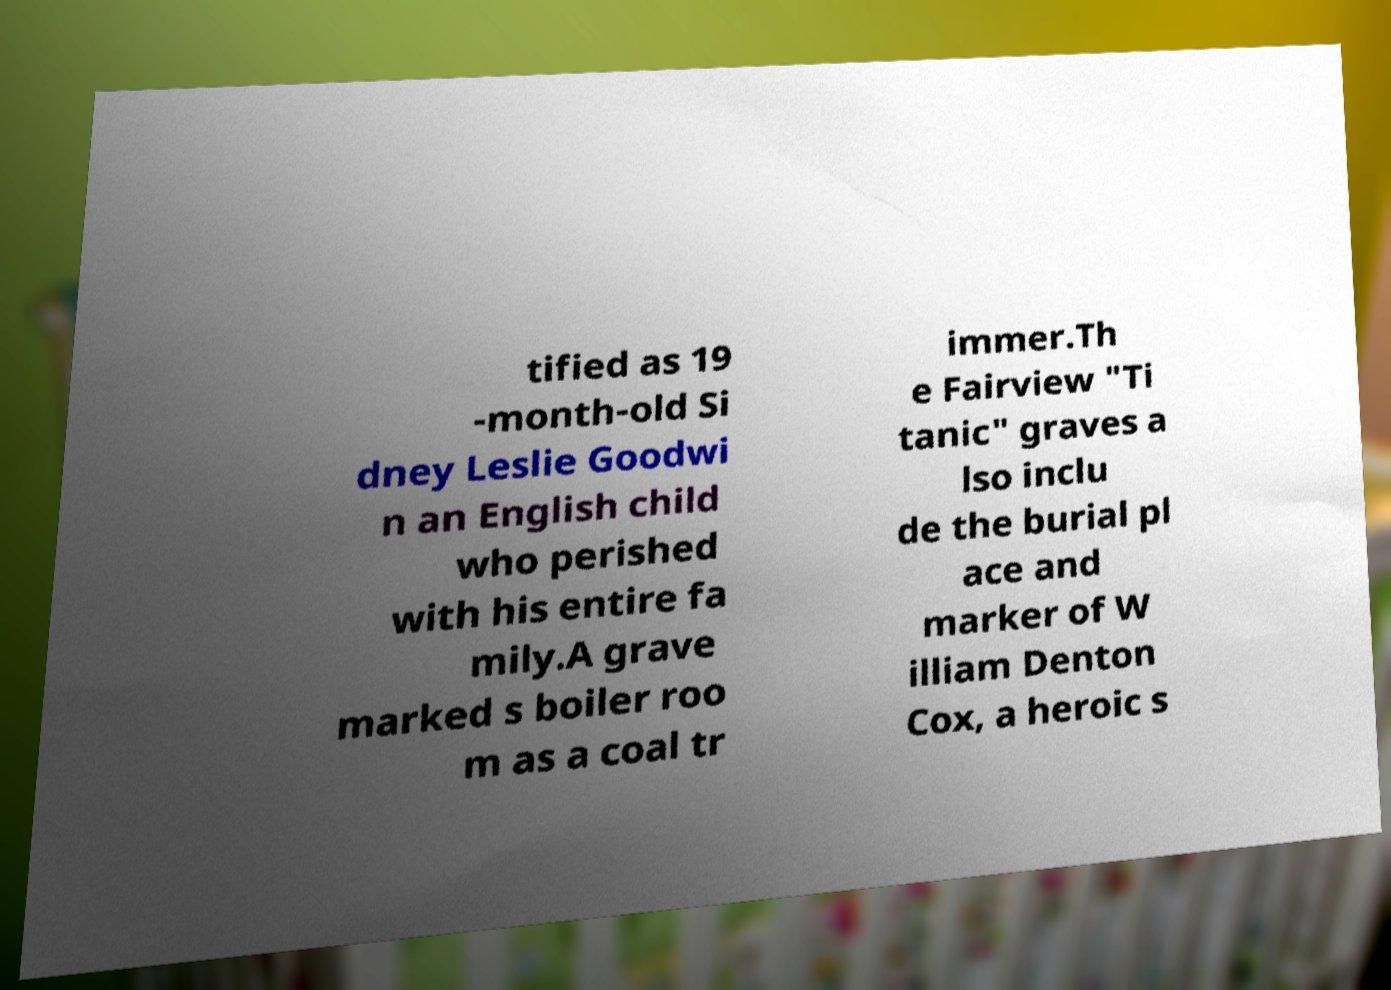For documentation purposes, I need the text within this image transcribed. Could you provide that? tified as 19 -month-old Si dney Leslie Goodwi n an English child who perished with his entire fa mily.A grave marked s boiler roo m as a coal tr immer.Th e Fairview "Ti tanic" graves a lso inclu de the burial pl ace and marker of W illiam Denton Cox, a heroic s 